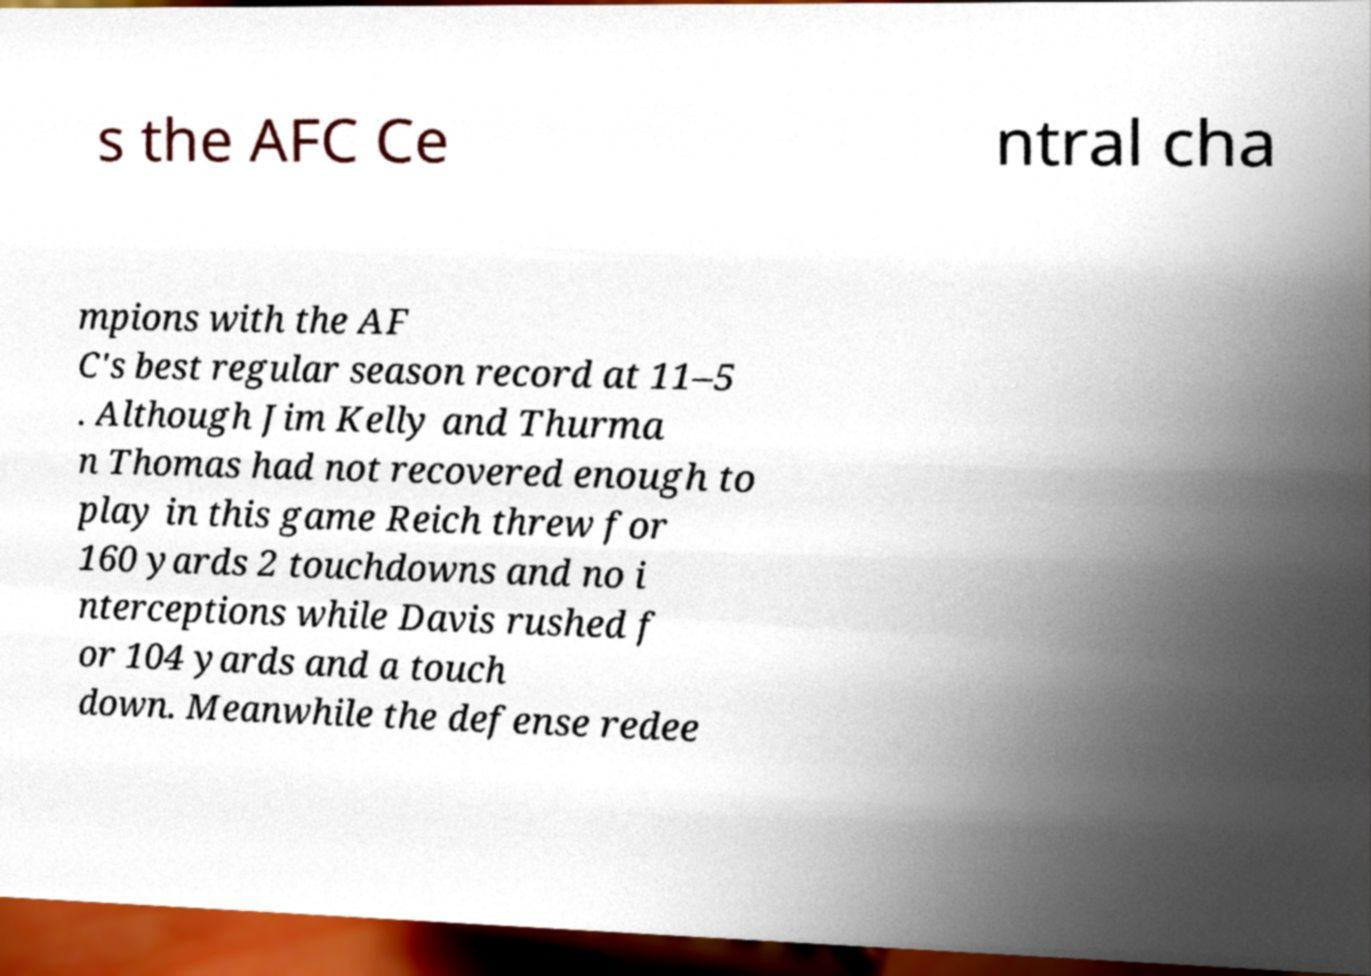I need the written content from this picture converted into text. Can you do that? s the AFC Ce ntral cha mpions with the AF C's best regular season record at 11–5 . Although Jim Kelly and Thurma n Thomas had not recovered enough to play in this game Reich threw for 160 yards 2 touchdowns and no i nterceptions while Davis rushed f or 104 yards and a touch down. Meanwhile the defense redee 